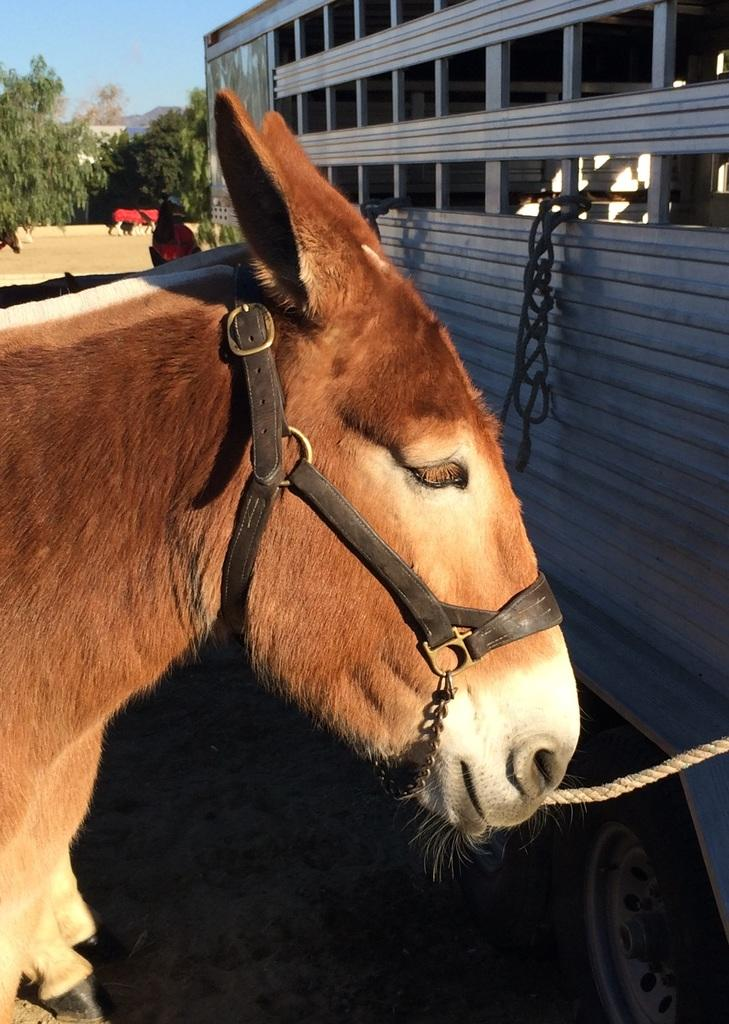What type of animal is in the image? There is an animal in the image, but the specific type cannot be determined from the provided facts. What is located in front of the animal in the image? There is a vehicle in front of the animal in the image. What can be seen in the background of the image, besides the animal? There are more animals and trees in the background of the image, as well as the sky. What type of store can be seen in the background of the image? There is no store present in the image; it features an animal, a vehicle, and a background with more animals, trees, and the sky. Can you tell me how many goldfish are swimming in the background of the image? There are no goldfish present in the image; it features an animal, a vehicle, and a background with more animals, trees, and the sky. 